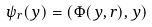Convert formula to latex. <formula><loc_0><loc_0><loc_500><loc_500>\psi _ { r } ( y ) = ( \Phi ( y , r ) , y )</formula> 